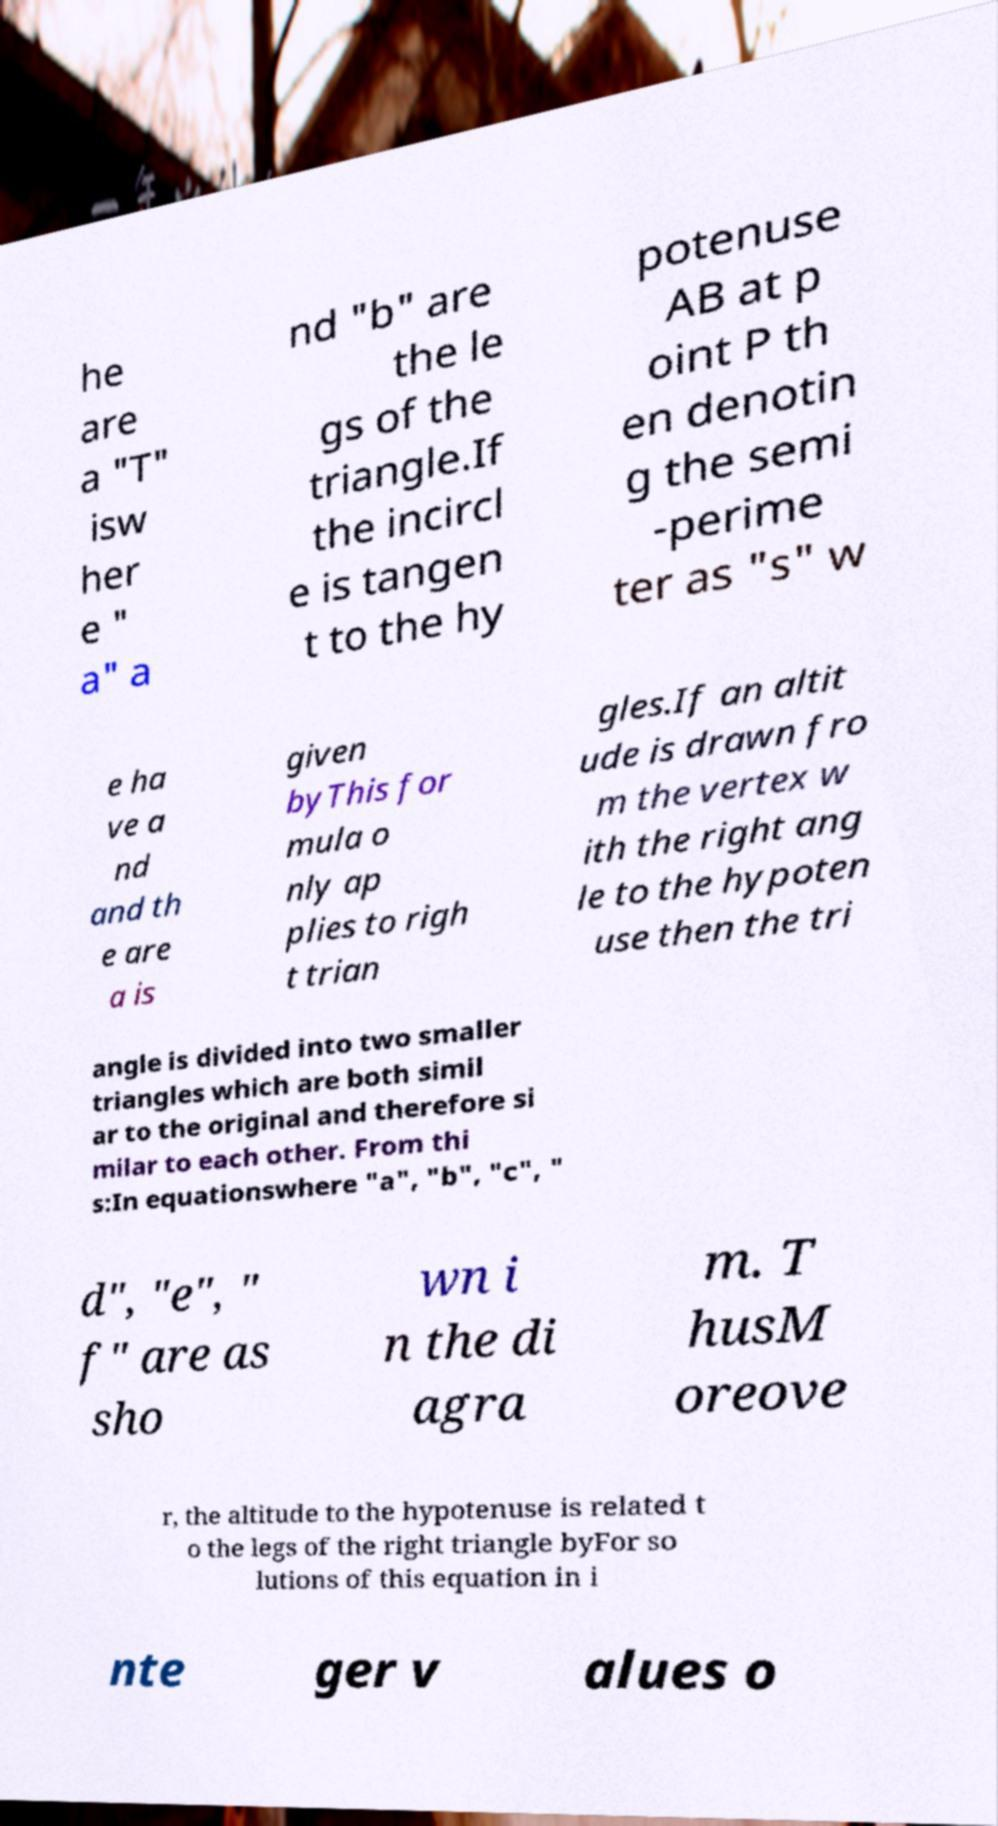What messages or text are displayed in this image? I need them in a readable, typed format. he are a "T" isw her e " a" a nd "b" are the le gs of the triangle.If the incircl e is tangen t to the hy potenuse AB at p oint P th en denotin g the semi -perime ter as "s" w e ha ve a nd and th e are a is given byThis for mula o nly ap plies to righ t trian gles.If an altit ude is drawn fro m the vertex w ith the right ang le to the hypoten use then the tri angle is divided into two smaller triangles which are both simil ar to the original and therefore si milar to each other. From thi s:In equationswhere "a", "b", "c", " d", "e", " f" are as sho wn i n the di agra m. T husM oreove r, the altitude to the hypotenuse is related t o the legs of the right triangle byFor so lutions of this equation in i nte ger v alues o 